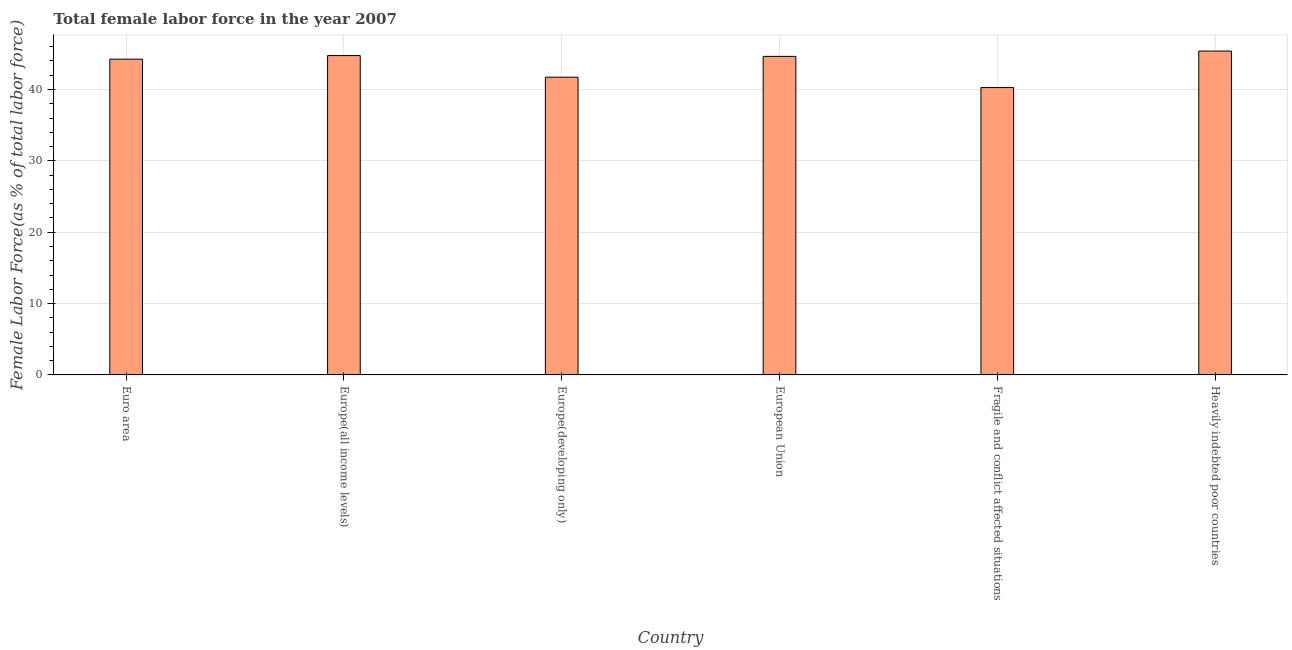Does the graph contain any zero values?
Provide a succinct answer. No. Does the graph contain grids?
Provide a succinct answer. Yes. What is the title of the graph?
Ensure brevity in your answer.  Total female labor force in the year 2007. What is the label or title of the X-axis?
Ensure brevity in your answer.  Country. What is the label or title of the Y-axis?
Your response must be concise. Female Labor Force(as % of total labor force). What is the total female labor force in Europe(all income levels)?
Your response must be concise. 44.75. Across all countries, what is the maximum total female labor force?
Make the answer very short. 45.38. Across all countries, what is the minimum total female labor force?
Your answer should be very brief. 40.27. In which country was the total female labor force maximum?
Your response must be concise. Heavily indebted poor countries. In which country was the total female labor force minimum?
Provide a short and direct response. Fragile and conflict affected situations. What is the sum of the total female labor force?
Offer a very short reply. 261.02. What is the difference between the total female labor force in Euro area and Fragile and conflict affected situations?
Provide a succinct answer. 3.98. What is the average total female labor force per country?
Your answer should be compact. 43.5. What is the median total female labor force?
Keep it short and to the point. 44.44. In how many countries, is the total female labor force greater than 30 %?
Your answer should be compact. 6. What is the ratio of the total female labor force in Euro area to that in European Union?
Offer a terse response. 0.99. Is the total female labor force in Europe(developing only) less than that in Fragile and conflict affected situations?
Provide a short and direct response. No. Is the difference between the total female labor force in Euro area and Europe(all income levels) greater than the difference between any two countries?
Your answer should be very brief. No. What is the difference between the highest and the second highest total female labor force?
Ensure brevity in your answer.  0.63. Is the sum of the total female labor force in Euro area and European Union greater than the maximum total female labor force across all countries?
Provide a succinct answer. Yes. What is the difference between the highest and the lowest total female labor force?
Give a very brief answer. 5.11. How many bars are there?
Give a very brief answer. 6. Are all the bars in the graph horizontal?
Your answer should be very brief. No. Are the values on the major ticks of Y-axis written in scientific E-notation?
Offer a very short reply. No. What is the Female Labor Force(as % of total labor force) in Euro area?
Offer a terse response. 44.25. What is the Female Labor Force(as % of total labor force) of Europe(all income levels)?
Your answer should be compact. 44.75. What is the Female Labor Force(as % of total labor force) of Europe(developing only)?
Offer a very short reply. 41.72. What is the Female Labor Force(as % of total labor force) in European Union?
Keep it short and to the point. 44.64. What is the Female Labor Force(as % of total labor force) in Fragile and conflict affected situations?
Give a very brief answer. 40.27. What is the Female Labor Force(as % of total labor force) in Heavily indebted poor countries?
Provide a short and direct response. 45.38. What is the difference between the Female Labor Force(as % of total labor force) in Euro area and Europe(all income levels)?
Make the answer very short. -0.5. What is the difference between the Female Labor Force(as % of total labor force) in Euro area and Europe(developing only)?
Make the answer very short. 2.53. What is the difference between the Female Labor Force(as % of total labor force) in Euro area and European Union?
Keep it short and to the point. -0.39. What is the difference between the Female Labor Force(as % of total labor force) in Euro area and Fragile and conflict affected situations?
Keep it short and to the point. 3.98. What is the difference between the Female Labor Force(as % of total labor force) in Euro area and Heavily indebted poor countries?
Offer a terse response. -1.13. What is the difference between the Female Labor Force(as % of total labor force) in Europe(all income levels) and Europe(developing only)?
Provide a short and direct response. 3.03. What is the difference between the Female Labor Force(as % of total labor force) in Europe(all income levels) and European Union?
Offer a terse response. 0.11. What is the difference between the Female Labor Force(as % of total labor force) in Europe(all income levels) and Fragile and conflict affected situations?
Offer a terse response. 4.48. What is the difference between the Female Labor Force(as % of total labor force) in Europe(all income levels) and Heavily indebted poor countries?
Keep it short and to the point. -0.63. What is the difference between the Female Labor Force(as % of total labor force) in Europe(developing only) and European Union?
Offer a terse response. -2.92. What is the difference between the Female Labor Force(as % of total labor force) in Europe(developing only) and Fragile and conflict affected situations?
Your answer should be very brief. 1.45. What is the difference between the Female Labor Force(as % of total labor force) in Europe(developing only) and Heavily indebted poor countries?
Keep it short and to the point. -3.66. What is the difference between the Female Labor Force(as % of total labor force) in European Union and Fragile and conflict affected situations?
Make the answer very short. 4.37. What is the difference between the Female Labor Force(as % of total labor force) in European Union and Heavily indebted poor countries?
Give a very brief answer. -0.74. What is the difference between the Female Labor Force(as % of total labor force) in Fragile and conflict affected situations and Heavily indebted poor countries?
Your answer should be compact. -5.11. What is the ratio of the Female Labor Force(as % of total labor force) in Euro area to that in Europe(developing only)?
Ensure brevity in your answer.  1.06. What is the ratio of the Female Labor Force(as % of total labor force) in Euro area to that in Fragile and conflict affected situations?
Keep it short and to the point. 1.1. What is the ratio of the Female Labor Force(as % of total labor force) in Euro area to that in Heavily indebted poor countries?
Your answer should be compact. 0.97. What is the ratio of the Female Labor Force(as % of total labor force) in Europe(all income levels) to that in Europe(developing only)?
Ensure brevity in your answer.  1.07. What is the ratio of the Female Labor Force(as % of total labor force) in Europe(all income levels) to that in Fragile and conflict affected situations?
Make the answer very short. 1.11. What is the ratio of the Female Labor Force(as % of total labor force) in Europe(developing only) to that in European Union?
Your response must be concise. 0.94. What is the ratio of the Female Labor Force(as % of total labor force) in Europe(developing only) to that in Fragile and conflict affected situations?
Your answer should be very brief. 1.04. What is the ratio of the Female Labor Force(as % of total labor force) in Europe(developing only) to that in Heavily indebted poor countries?
Your answer should be very brief. 0.92. What is the ratio of the Female Labor Force(as % of total labor force) in European Union to that in Fragile and conflict affected situations?
Your answer should be very brief. 1.11. What is the ratio of the Female Labor Force(as % of total labor force) in Fragile and conflict affected situations to that in Heavily indebted poor countries?
Your answer should be very brief. 0.89. 